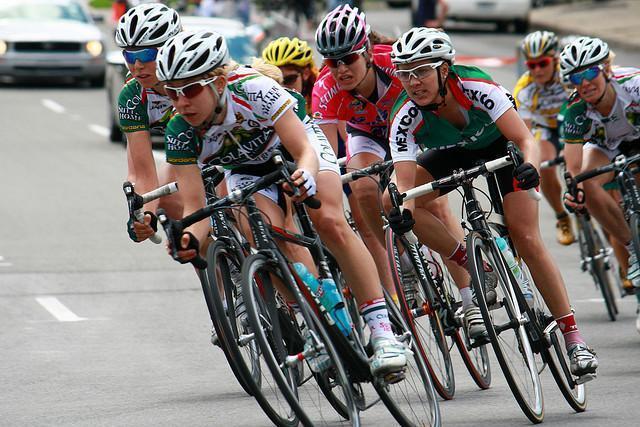How many people can be seen?
Give a very brief answer. 7. How many bicycles are there?
Give a very brief answer. 7. How many cars are there?
Give a very brief answer. 2. How many cats are on the umbrella?
Give a very brief answer. 0. 